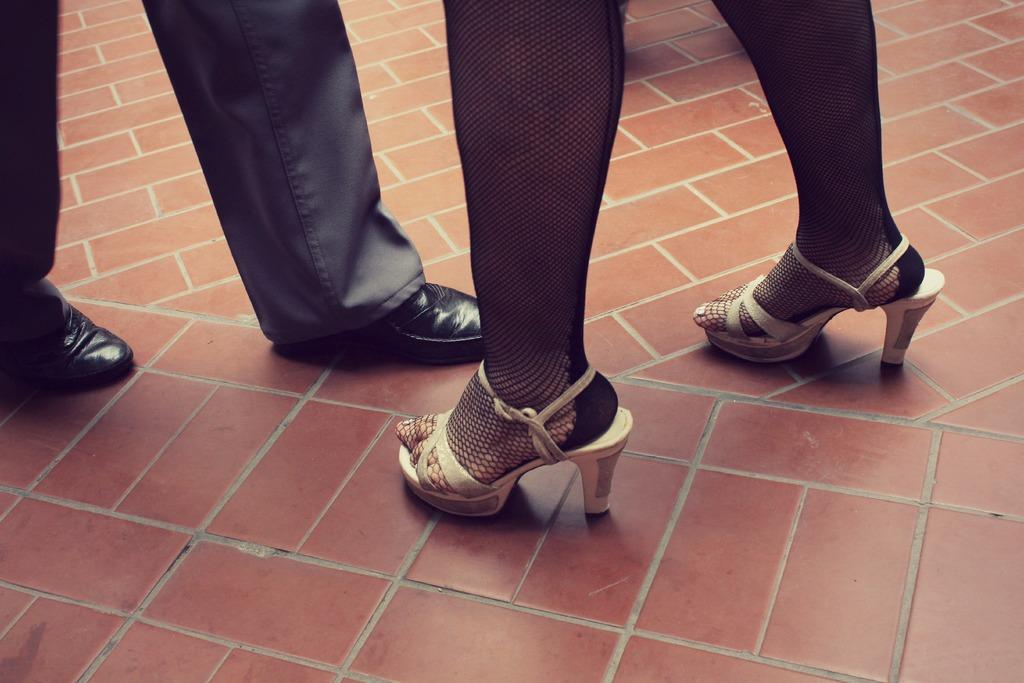What body parts are visible in the image? There are persons' legs visible in the image. What is covering the persons' feet in the image? The legs have footwear on them. Where are the legs and footwear located in the image? The legs and footwear are on the floor. What type of bone can be seen in the image? There is no bone present in the image; it features persons' legs with footwear. What type of table is visible in the image? There is no table present in the image; it only shows persons' legs with footwear on the floor. 